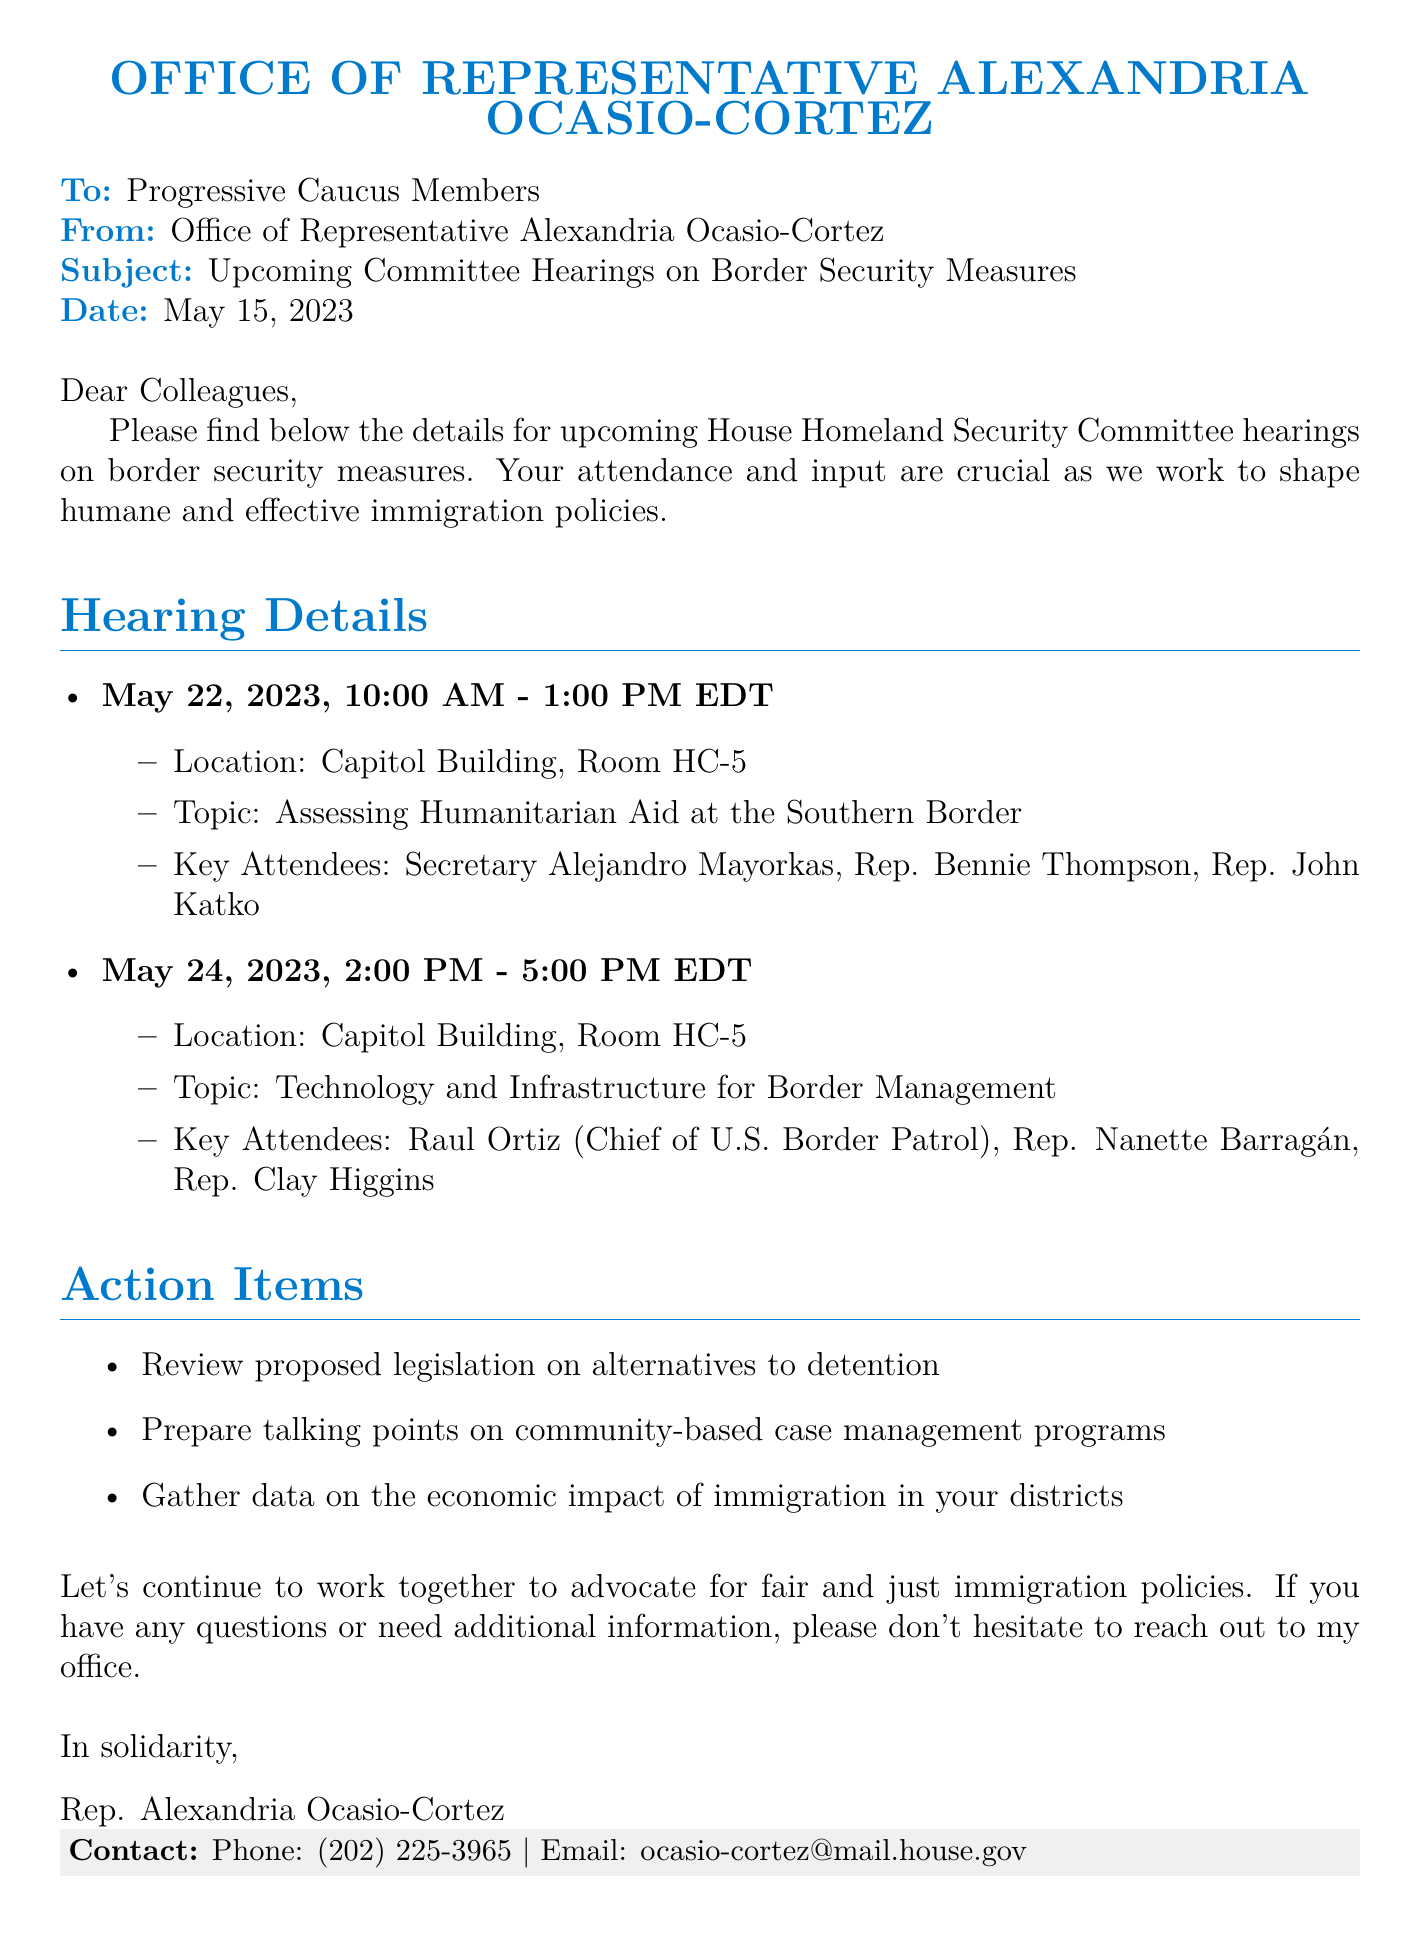What date is the first hearing scheduled? The first hearing is scheduled for May 22, 2023.
Answer: May 22, 2023 Who will be attending the hearing on May 24, 2023? The key attendees for the May 24 hearing include Raul Ortiz, Rep. Nanette Barragán, and Rep. Clay Higgins.
Answer: Raul Ortiz, Rep. Nanette Barragán, Rep. Clay Higgins What is the topic of the hearing on May 22, 2023? The topic of the May 22 hearing is "Assessing Humanitarian Aid at the Southern Border."
Answer: Assessing Humanitarian Aid at the Southern Border How long is each hearing scheduled to last? Each hearing is scheduled to last three hours.
Answer: Three hours What is the location for both hearings? Both hearings are located in Capitol Building, Room HC-5.
Answer: Capitol Building, Room HC-5 What action item involves gathering data? The action item involves gathering data on the economic impact of immigration in your districts.
Answer: Gather data on the economic impact of immigration in your districts Who is the sender of the memo? The memo is sent by the Office of Representative Alexandria Ocasio-Cortez.
Answer: Office of Representative Alexandria Ocasio-Cortez What is the contact number provided in the document? The contact number provided is (202) 225-3965.
Answer: (202) 225-3965 